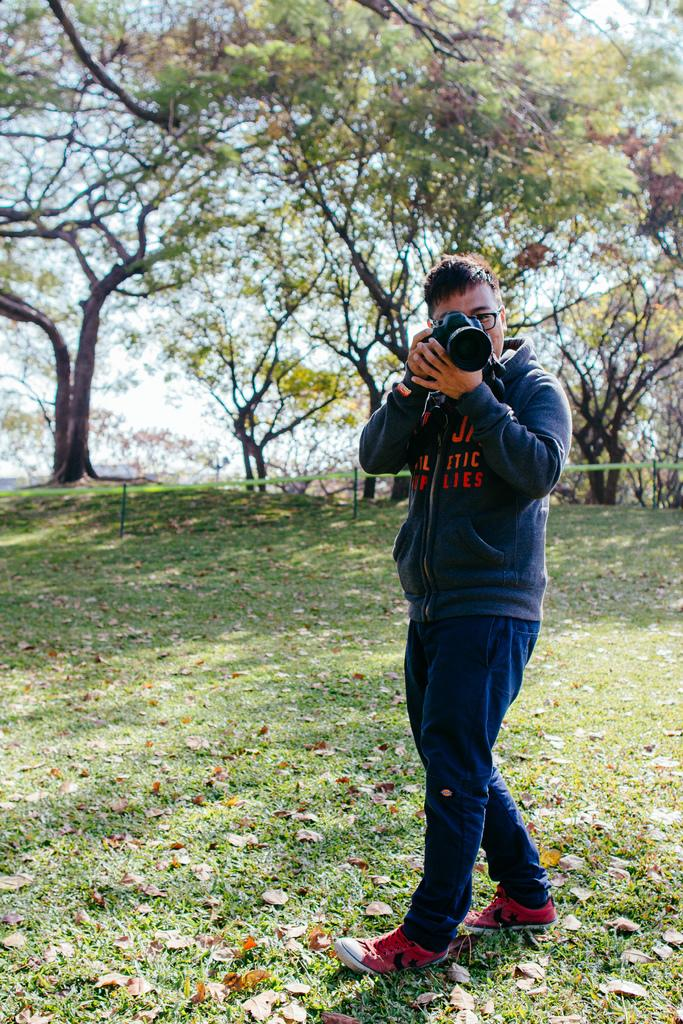Who is present in the image? There is a man in the image. What is the man wearing? The man is wearing a jacket. What is the man holding in the image? The man is holding a camera. How would you describe the land in the image? The land is covered with grass, and there are dried leaves on the grass. What can be seen in the background of the image? There are trees in the background of the image. What type of hair growth can be seen on the man's head in the image? There is no information about the man's hair in the image, so we cannot determine the type of hair growth. 